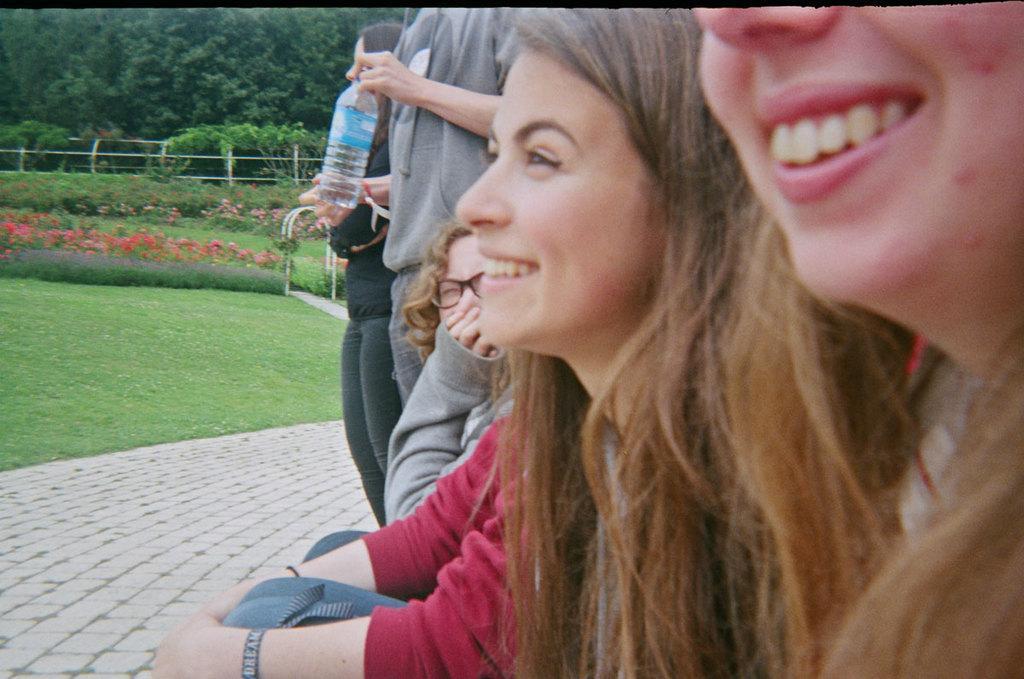How would you summarize this image in a sentence or two? In the center of the image we can see a few people. Among them, we can see two persons are smiling and one person is holding one water bottle. In the background, we can see trees, plants, flowers, grass and fence. 